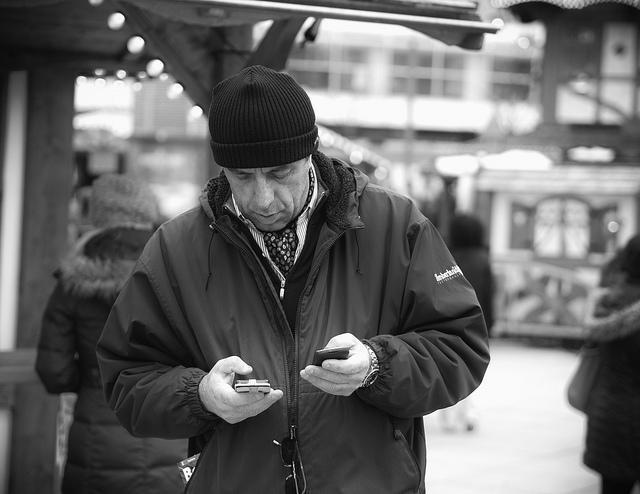How many people are in the picture?
Give a very brief answer. 4. 